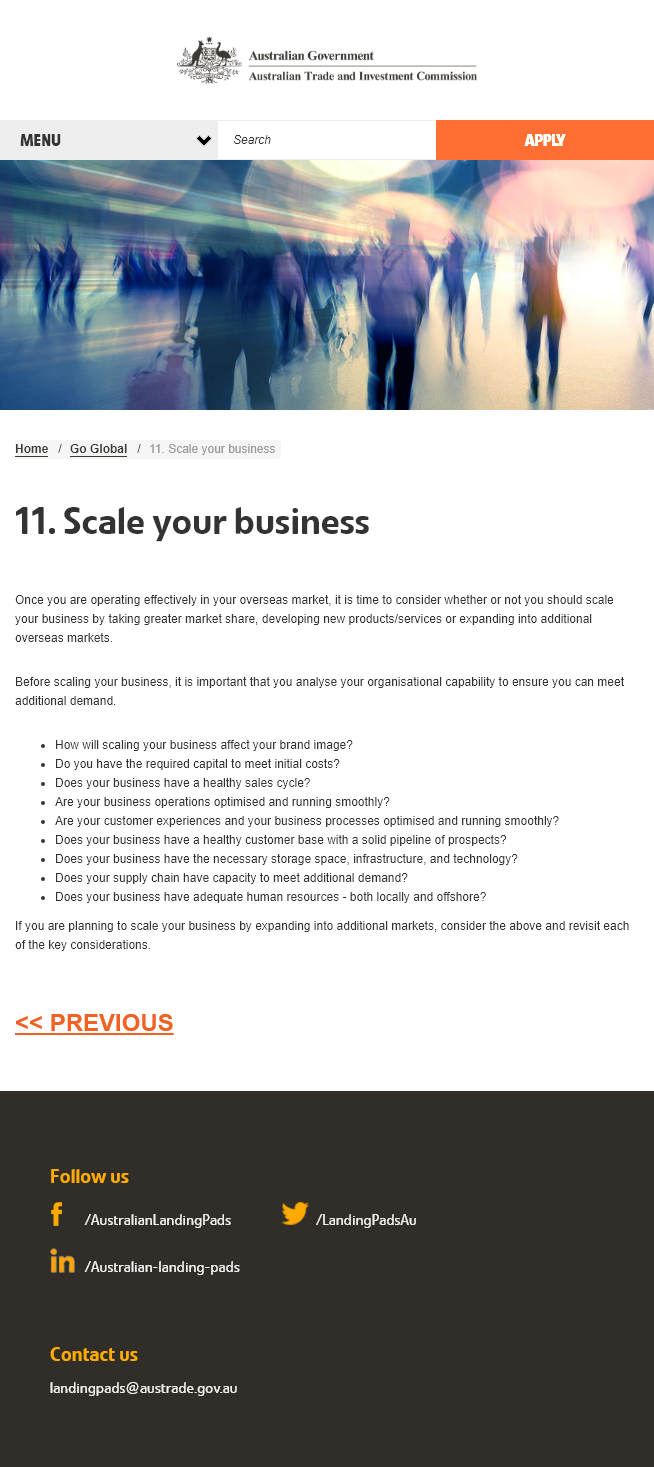Point out several critical features in this image. In addition to increasing our market share, there are two other methods that can be utilized to scale our business: the development of new products and services, and the expansion into additional overseas markets. Before scaling up your business, it is crucial to analyze your organizational capability to determine if you have the capacity to meet the increased demand. Three methods for scaling up a business are discussed in section 11. 